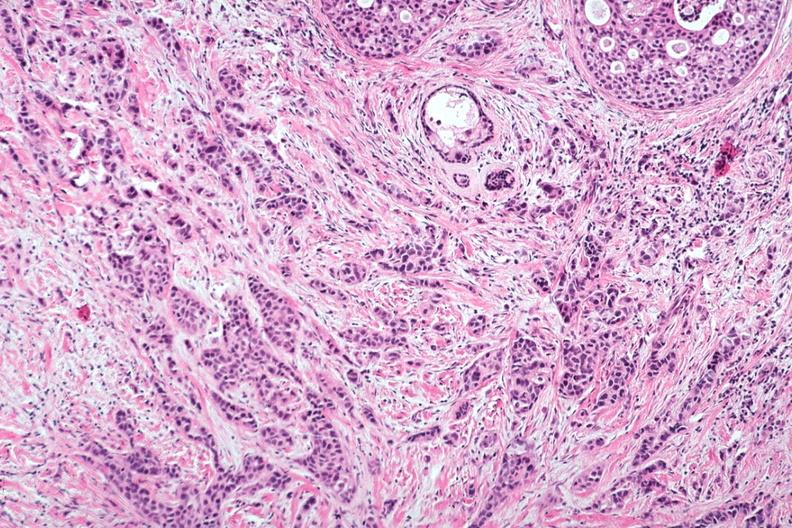does leiomyosarcoma show excellent invasive tumor with marked desmoplastic reaction?
Answer the question using a single word or phrase. No 